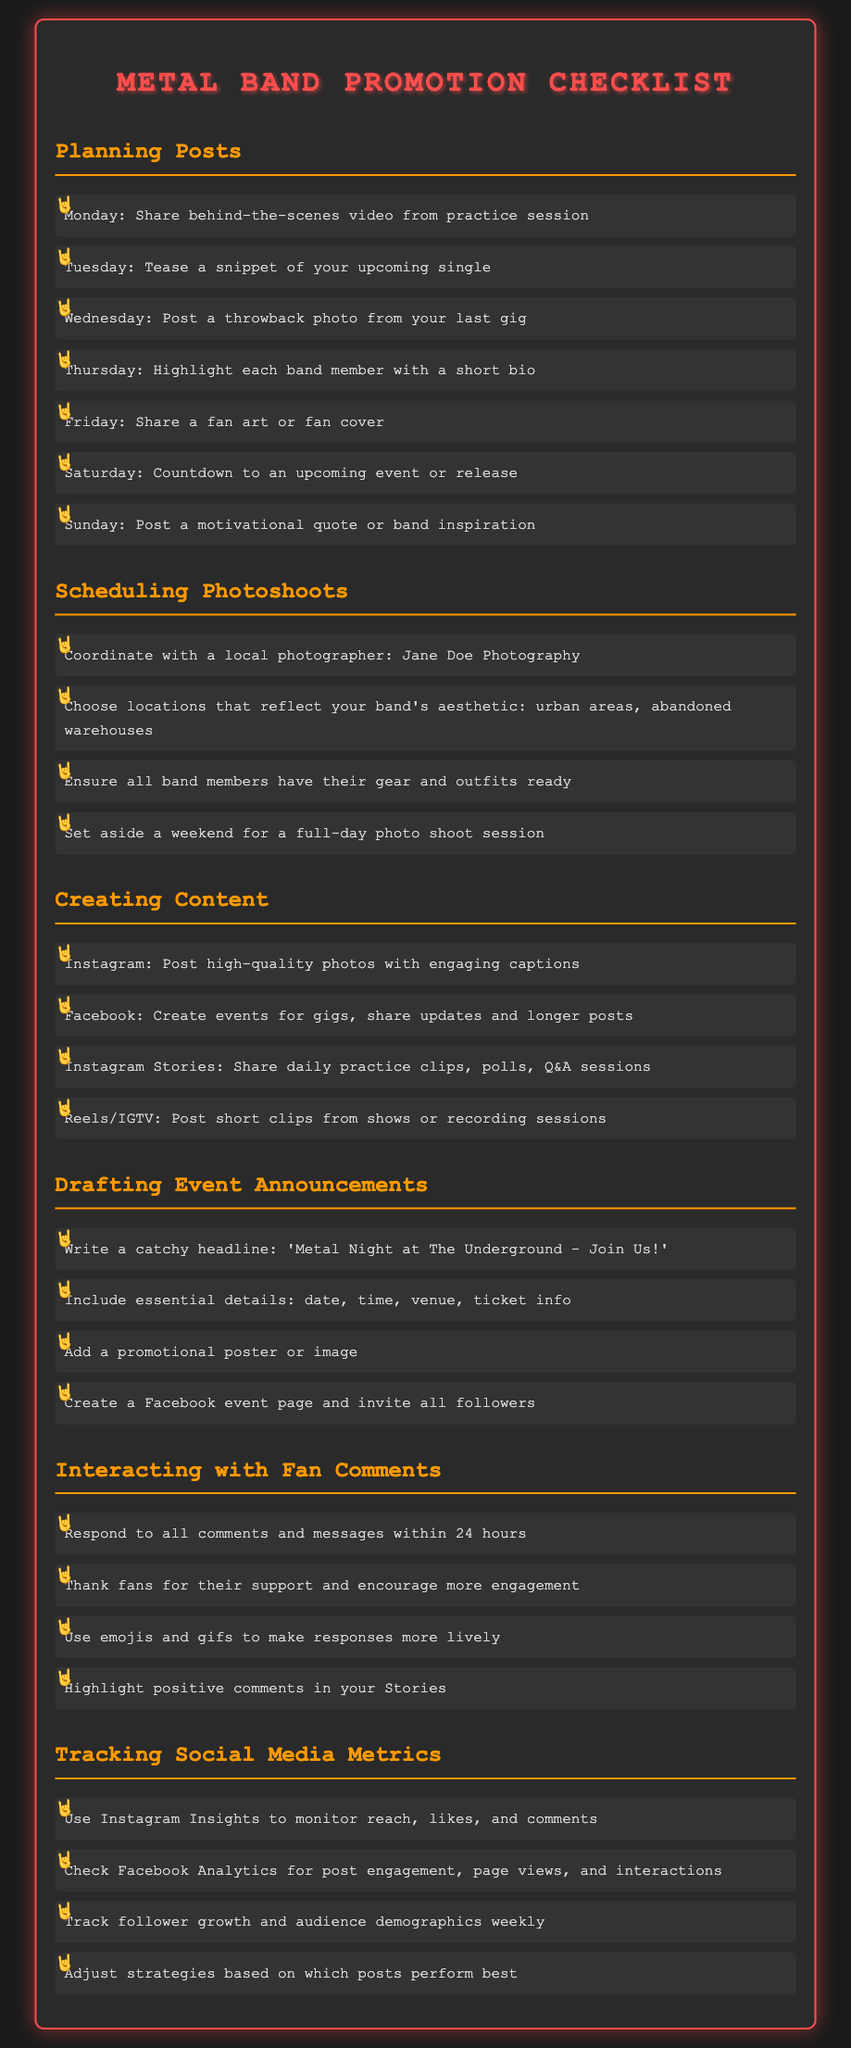What day is the band sharing a behind-the-scenes video? The document states that the band will share a behind-the-scenes video from the practice session on Monday.
Answer: Monday Who is the local photographer mentioned for photoshoots? The checklist mentions Jane Doe Photography as the local photographer for coordinating photoshoots.
Answer: Jane Doe Photography What type of content is suggested for Instagram Stories? The document lists sharing daily practice clips, polls, and Q&A sessions as content for Instagram Stories.
Answer: Daily practice clips, polls, Q&A sessions What essential details should be included in event announcements? The checklist specifies that essential details include date, time, venue, and ticket information.
Answer: Date, time, venue, ticket info How often should the band respond to fan comments? The guideline suggests that the band should respond to all comments and messages within 24 hours.
Answer: 24 hours What do you highlight in Instagram Insights? The document indicates that reach, likes, and comments are monitored using Instagram Insights.
Answer: Reach, likes, comments What motivational content is suggested for Sundays? The checklist recommends posting a motivational quote or band inspiration for Sundays.
Answer: Motivational quote How many items are suggested for scheduling photoshoots? The document lists four specific items for scheduling photoshoots.
Answer: Four What should be included in a promotional poster? The checklist states that a promotional poster or image should be added to the event announcement.
Answer: Promotional poster or image 